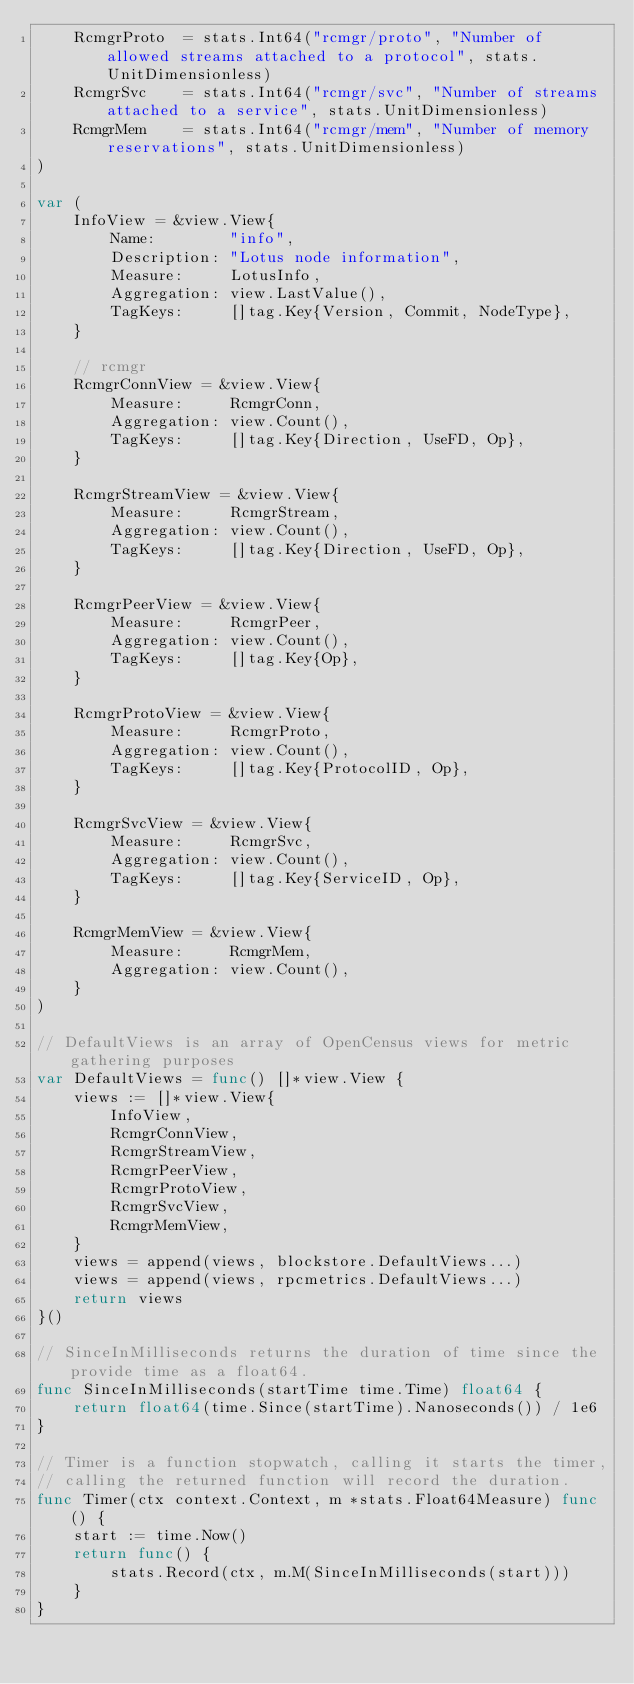<code> <loc_0><loc_0><loc_500><loc_500><_Go_>	RcmgrProto  = stats.Int64("rcmgr/proto", "Number of allowed streams attached to a protocol", stats.UnitDimensionless)
	RcmgrSvc    = stats.Int64("rcmgr/svc", "Number of streams attached to a service", stats.UnitDimensionless)
	RcmgrMem    = stats.Int64("rcmgr/mem", "Number of memory reservations", stats.UnitDimensionless)
)

var (
	InfoView = &view.View{
		Name:        "info",
		Description: "Lotus node information",
		Measure:     LotusInfo,
		Aggregation: view.LastValue(),
		TagKeys:     []tag.Key{Version, Commit, NodeType},
	}

	// rcmgr
	RcmgrConnView = &view.View{
		Measure:     RcmgrConn,
		Aggregation: view.Count(),
		TagKeys:     []tag.Key{Direction, UseFD, Op},
	}

	RcmgrStreamView = &view.View{
		Measure:     RcmgrStream,
		Aggregation: view.Count(),
		TagKeys:     []tag.Key{Direction, UseFD, Op},
	}

	RcmgrPeerView = &view.View{
		Measure:     RcmgrPeer,
		Aggregation: view.Count(),
		TagKeys:     []tag.Key{Op},
	}

	RcmgrProtoView = &view.View{
		Measure:     RcmgrProto,
		Aggregation: view.Count(),
		TagKeys:     []tag.Key{ProtocolID, Op},
	}

	RcmgrSvcView = &view.View{
		Measure:     RcmgrSvc,
		Aggregation: view.Count(),
		TagKeys:     []tag.Key{ServiceID, Op},
	}

	RcmgrMemView = &view.View{
		Measure:     RcmgrMem,
		Aggregation: view.Count(),
	}
)

// DefaultViews is an array of OpenCensus views for metric gathering purposes
var DefaultViews = func() []*view.View {
	views := []*view.View{
		InfoView,
		RcmgrConnView,
		RcmgrStreamView,
		RcmgrPeerView,
		RcmgrProtoView,
		RcmgrSvcView,
		RcmgrMemView,
	}
	views = append(views, blockstore.DefaultViews...)
	views = append(views, rpcmetrics.DefaultViews...)
	return views
}()

// SinceInMilliseconds returns the duration of time since the provide time as a float64.
func SinceInMilliseconds(startTime time.Time) float64 {
	return float64(time.Since(startTime).Nanoseconds()) / 1e6
}

// Timer is a function stopwatch, calling it starts the timer,
// calling the returned function will record the duration.
func Timer(ctx context.Context, m *stats.Float64Measure) func() {
	start := time.Now()
	return func() {
		stats.Record(ctx, m.M(SinceInMilliseconds(start)))
	}
}
</code> 